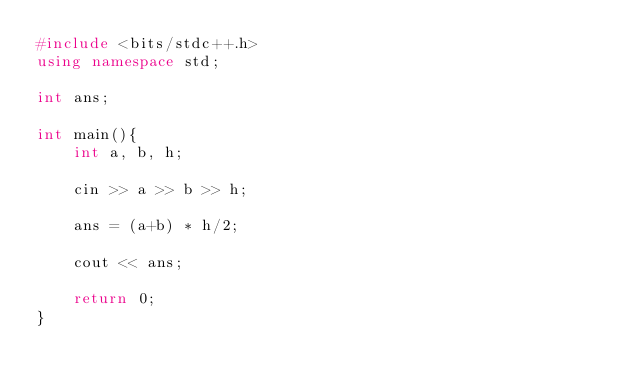<code> <loc_0><loc_0><loc_500><loc_500><_C++_>#include <bits/stdc++.h>
using namespace std;

int ans;

int main(){
	int a, b, h;
	
	cin >> a >> b >> h;
	
	ans = (a+b) * h/2;
	
	cout << ans;
	
	return 0;
}
</code> 